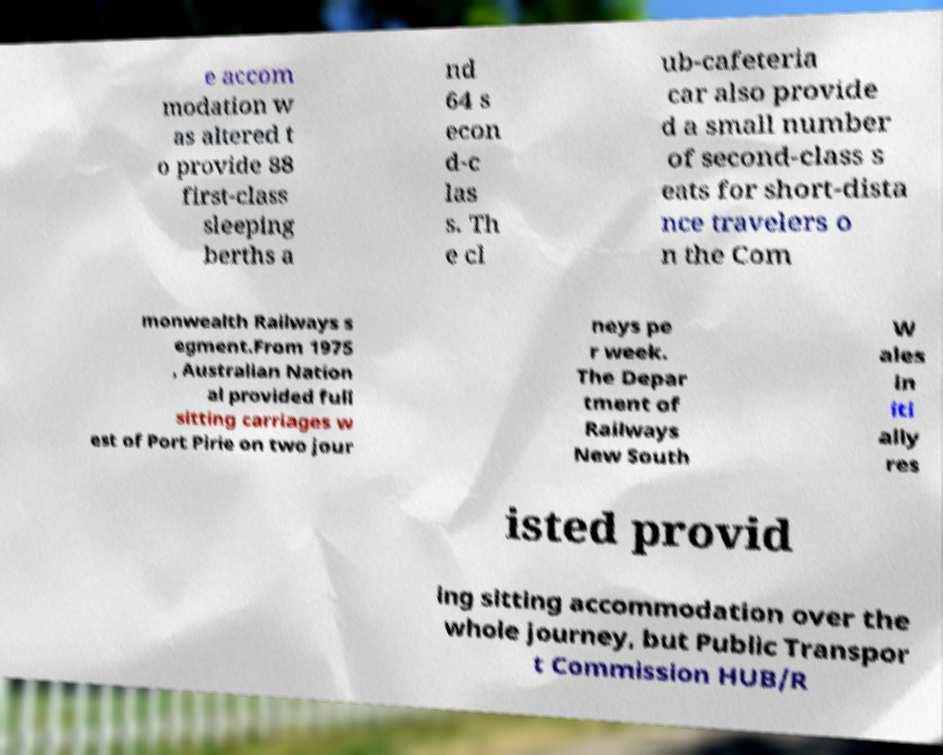There's text embedded in this image that I need extracted. Can you transcribe it verbatim? e accom modation w as altered t o provide 88 first-class sleeping berths a nd 64 s econ d-c las s. Th e cl ub-cafeteria car also provide d a small number of second-class s eats for short-dista nce travelers o n the Com monwealth Railways s egment.From 1975 , Australian Nation al provided full sitting carriages w est of Port Pirie on two jour neys pe r week. The Depar tment of Railways New South W ales in iti ally res isted provid ing sitting accommodation over the whole journey, but Public Transpor t Commission HUB/R 